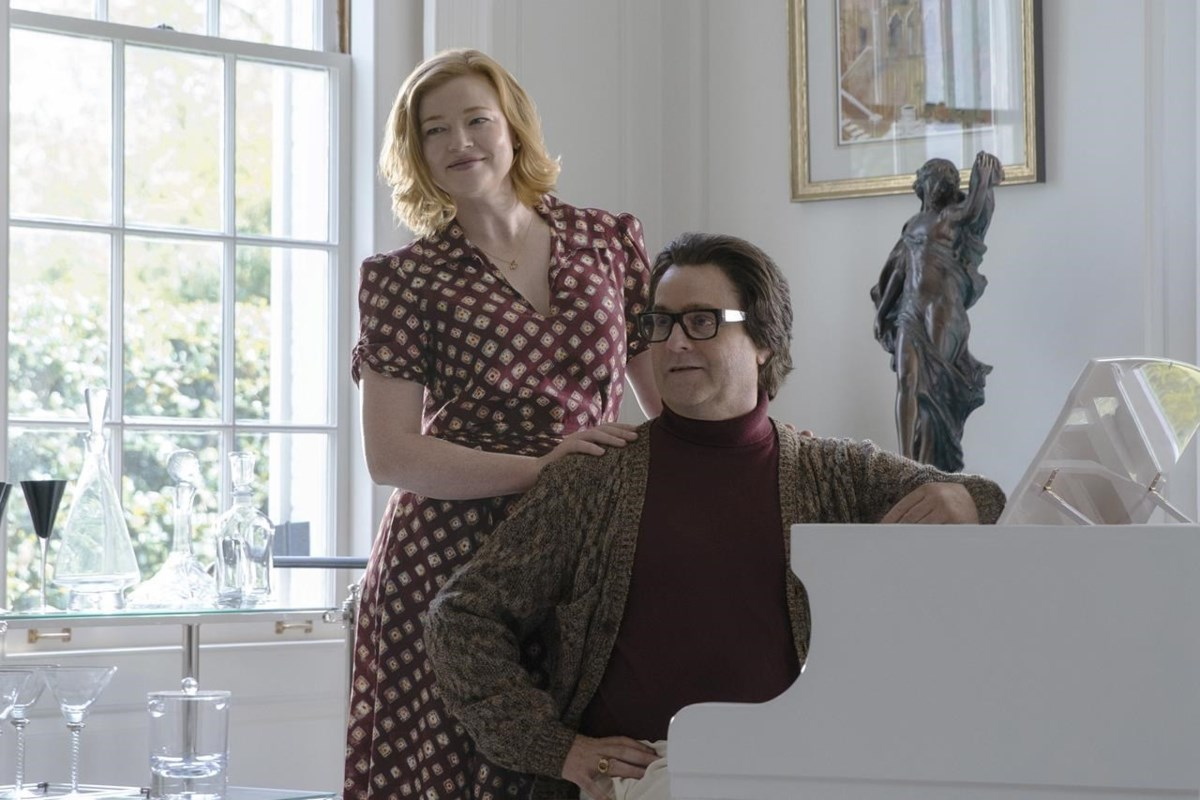Imagine the statue in the background suddenly came to life. What would happen next? As the melody from the piano reaches a crescendo, the statue in the background begins to shimmer. In a swirl of light and elegance, it gracefully steps off its pedestal, transforming into a living, breathing embodiment of art. This mystical being, once stone, now shares their story through a silent dance in rhythm with the piano’s tune. The room fills with an ethereal glow, and the characters watch in awe as the living statue performs a dance that narrates the history of creativity and artistry. This magical moment becomes a cherished memory, highlighting the power of art's influence from the past to the present. 